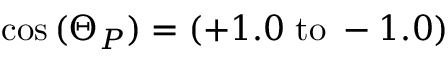<formula> <loc_0><loc_0><loc_500><loc_500>\cos { ( \Theta _ { P } ) } = ( + 1 . 0 \, { t o } \, - 1 . 0 )</formula> 